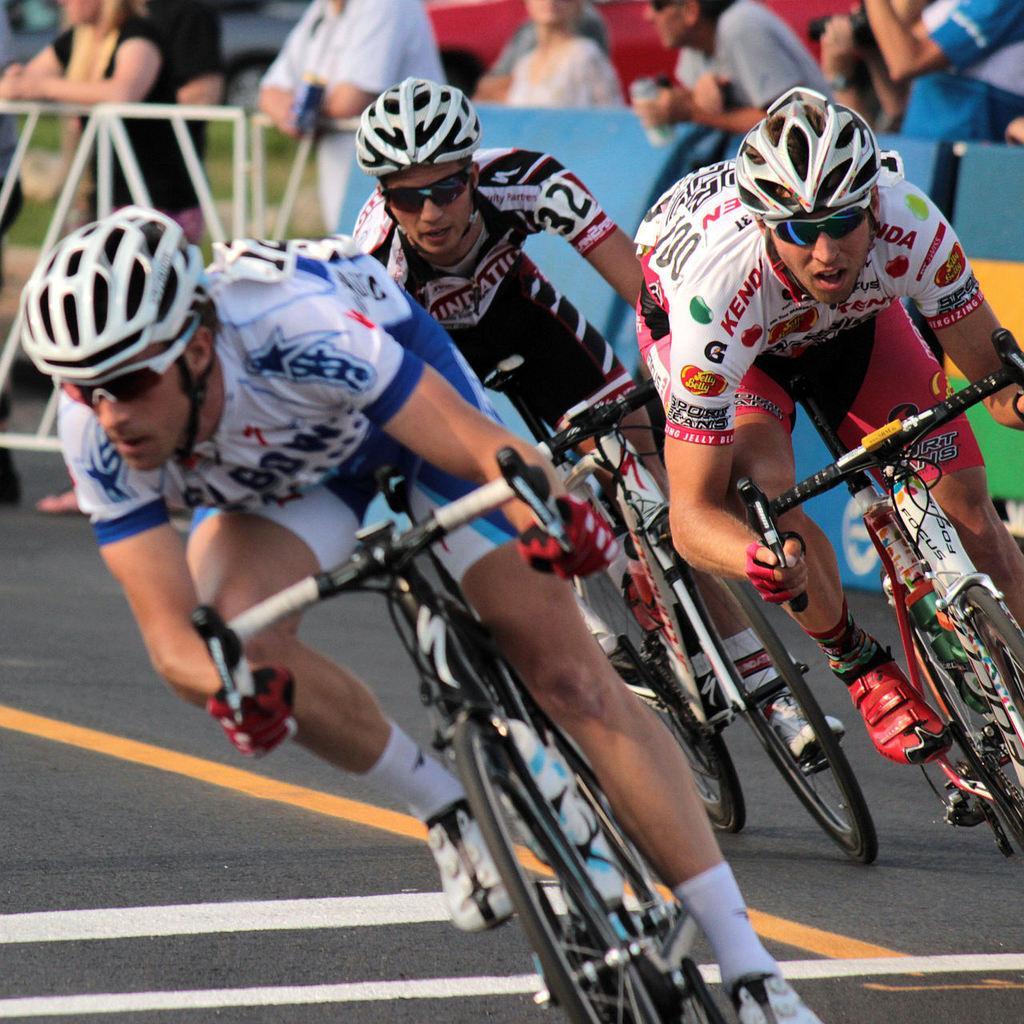Describe this image in one or two sentences. In this picture there are three people riding a bicycle and there is crowd behind them 